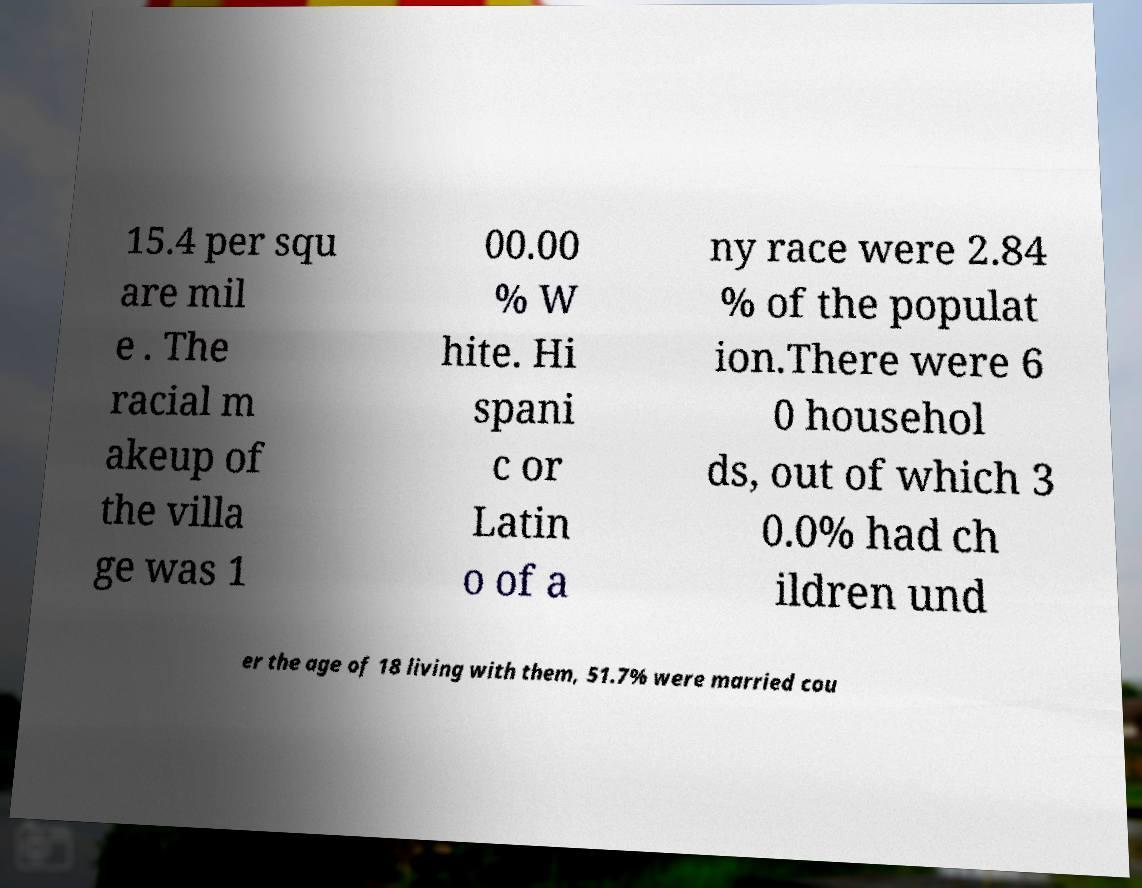Please read and relay the text visible in this image. What does it say? 15.4 per squ are mil e . The racial m akeup of the villa ge was 1 00.00 % W hite. Hi spani c or Latin o of a ny race were 2.84 % of the populat ion.There were 6 0 househol ds, out of which 3 0.0% had ch ildren und er the age of 18 living with them, 51.7% were married cou 